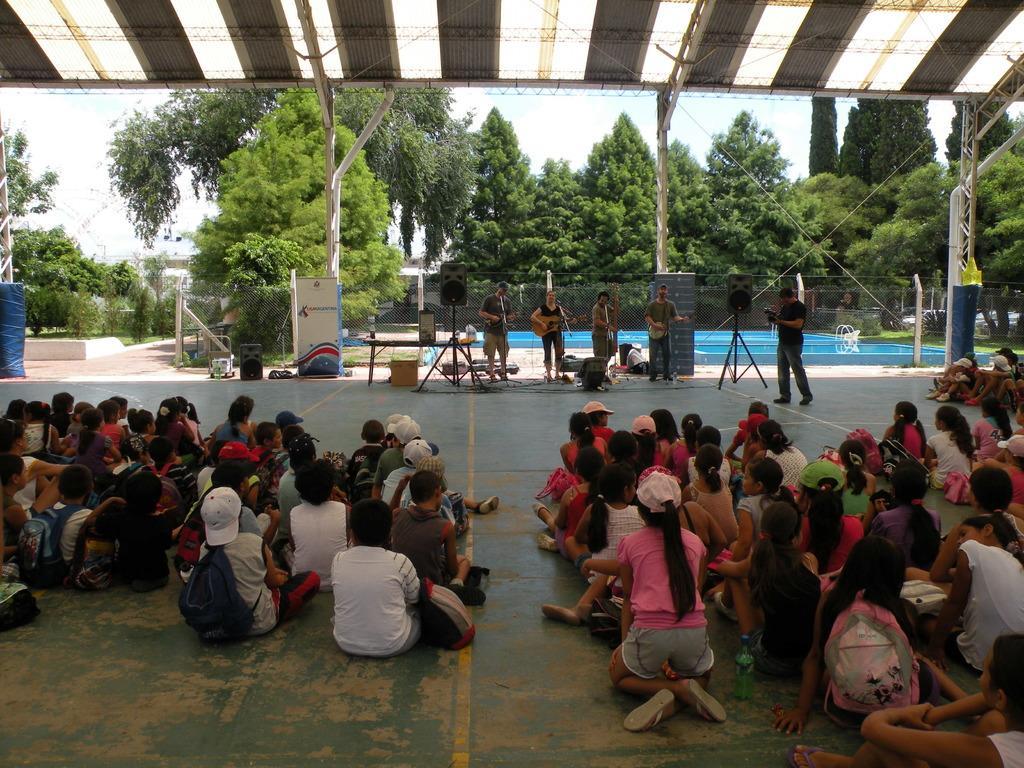Describe this image in one or two sentences. Here in this picture in the front we can see number of people sitting on the floor and in front of them we can see a group of people standing and playing musical instruments and we can also see speakers present and at the top we can see a tent present and on the right side we can see a person recording everything with a video camera in his hand and in the far we can see plants and trees present and we can also see a fencing present and we can see the sky is clear. 